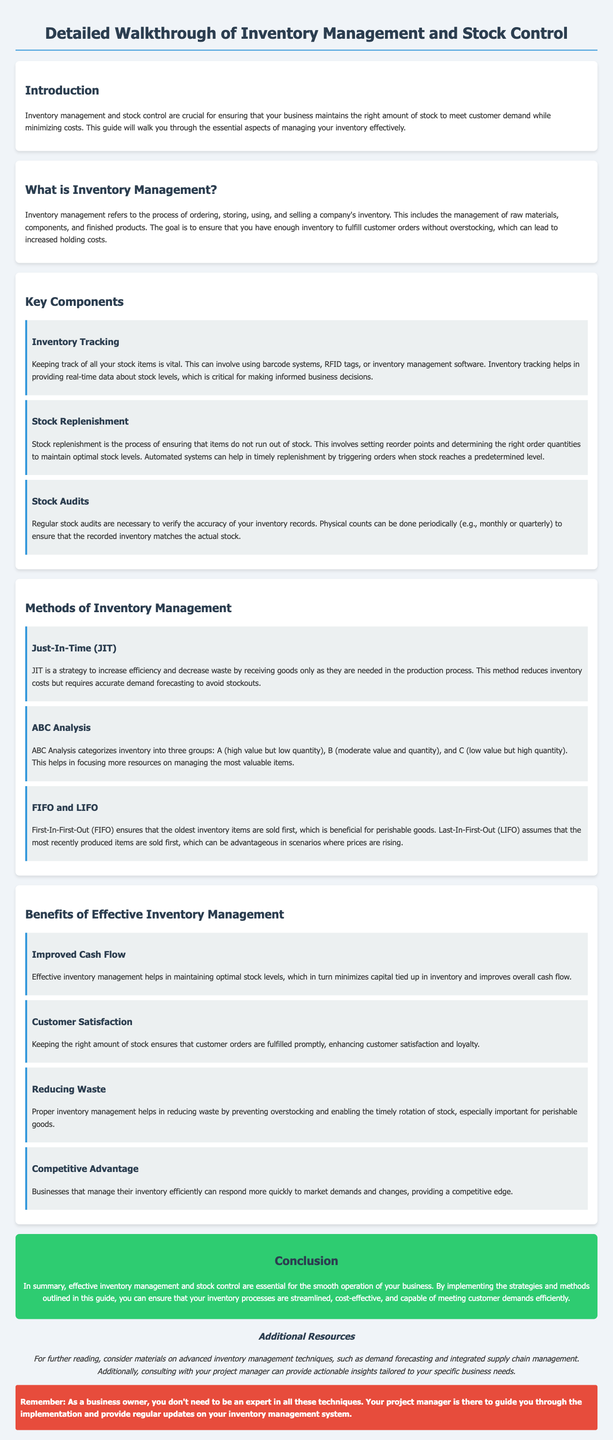What is the primary purpose of inventory management? The primary purpose is to maintain the right amount of stock to meet customer demand while minimizing costs.
Answer: Maintain stock levels What are the three categories in ABC Analysis? ABC Analysis categorizes inventory into three groups based on value and quantity: A, B, and C.
Answer: A, B, C What method ensures that the oldest inventory items are sold first? This method is called First-In-First-Out (FIFO).
Answer: FIFO How does effective inventory management improve cash flow? Effective management minimizes capital tied up in inventory, leading to improved cash flow.
Answer: Optimal stock levels What happens during stock audits? Stock audits involve verifying the accuracy of inventory records through physical counts.
Answer: Physical counts What is one benefit of having proper inventory management regarding customer satisfaction? Proper management ensures customer orders are fulfilled promptly, which enhances satisfaction.
Answer: Fulfilled orders What is one challenge of Just-In-Time (JIT) inventory management? JIT requires accurate demand forecasting to avoid stockouts.
Answer: Accurate forecasting What is emphasized as a significant part of inventory tracking? Real-time data about stock levels is emphasized for informed business decisions.
Answer: Real-time data Which section of the document discusses advantages of effective inventory management? The section is titled "Benefits of Effective Inventory Management."
Answer: Benefits of Effective Inventory Management 